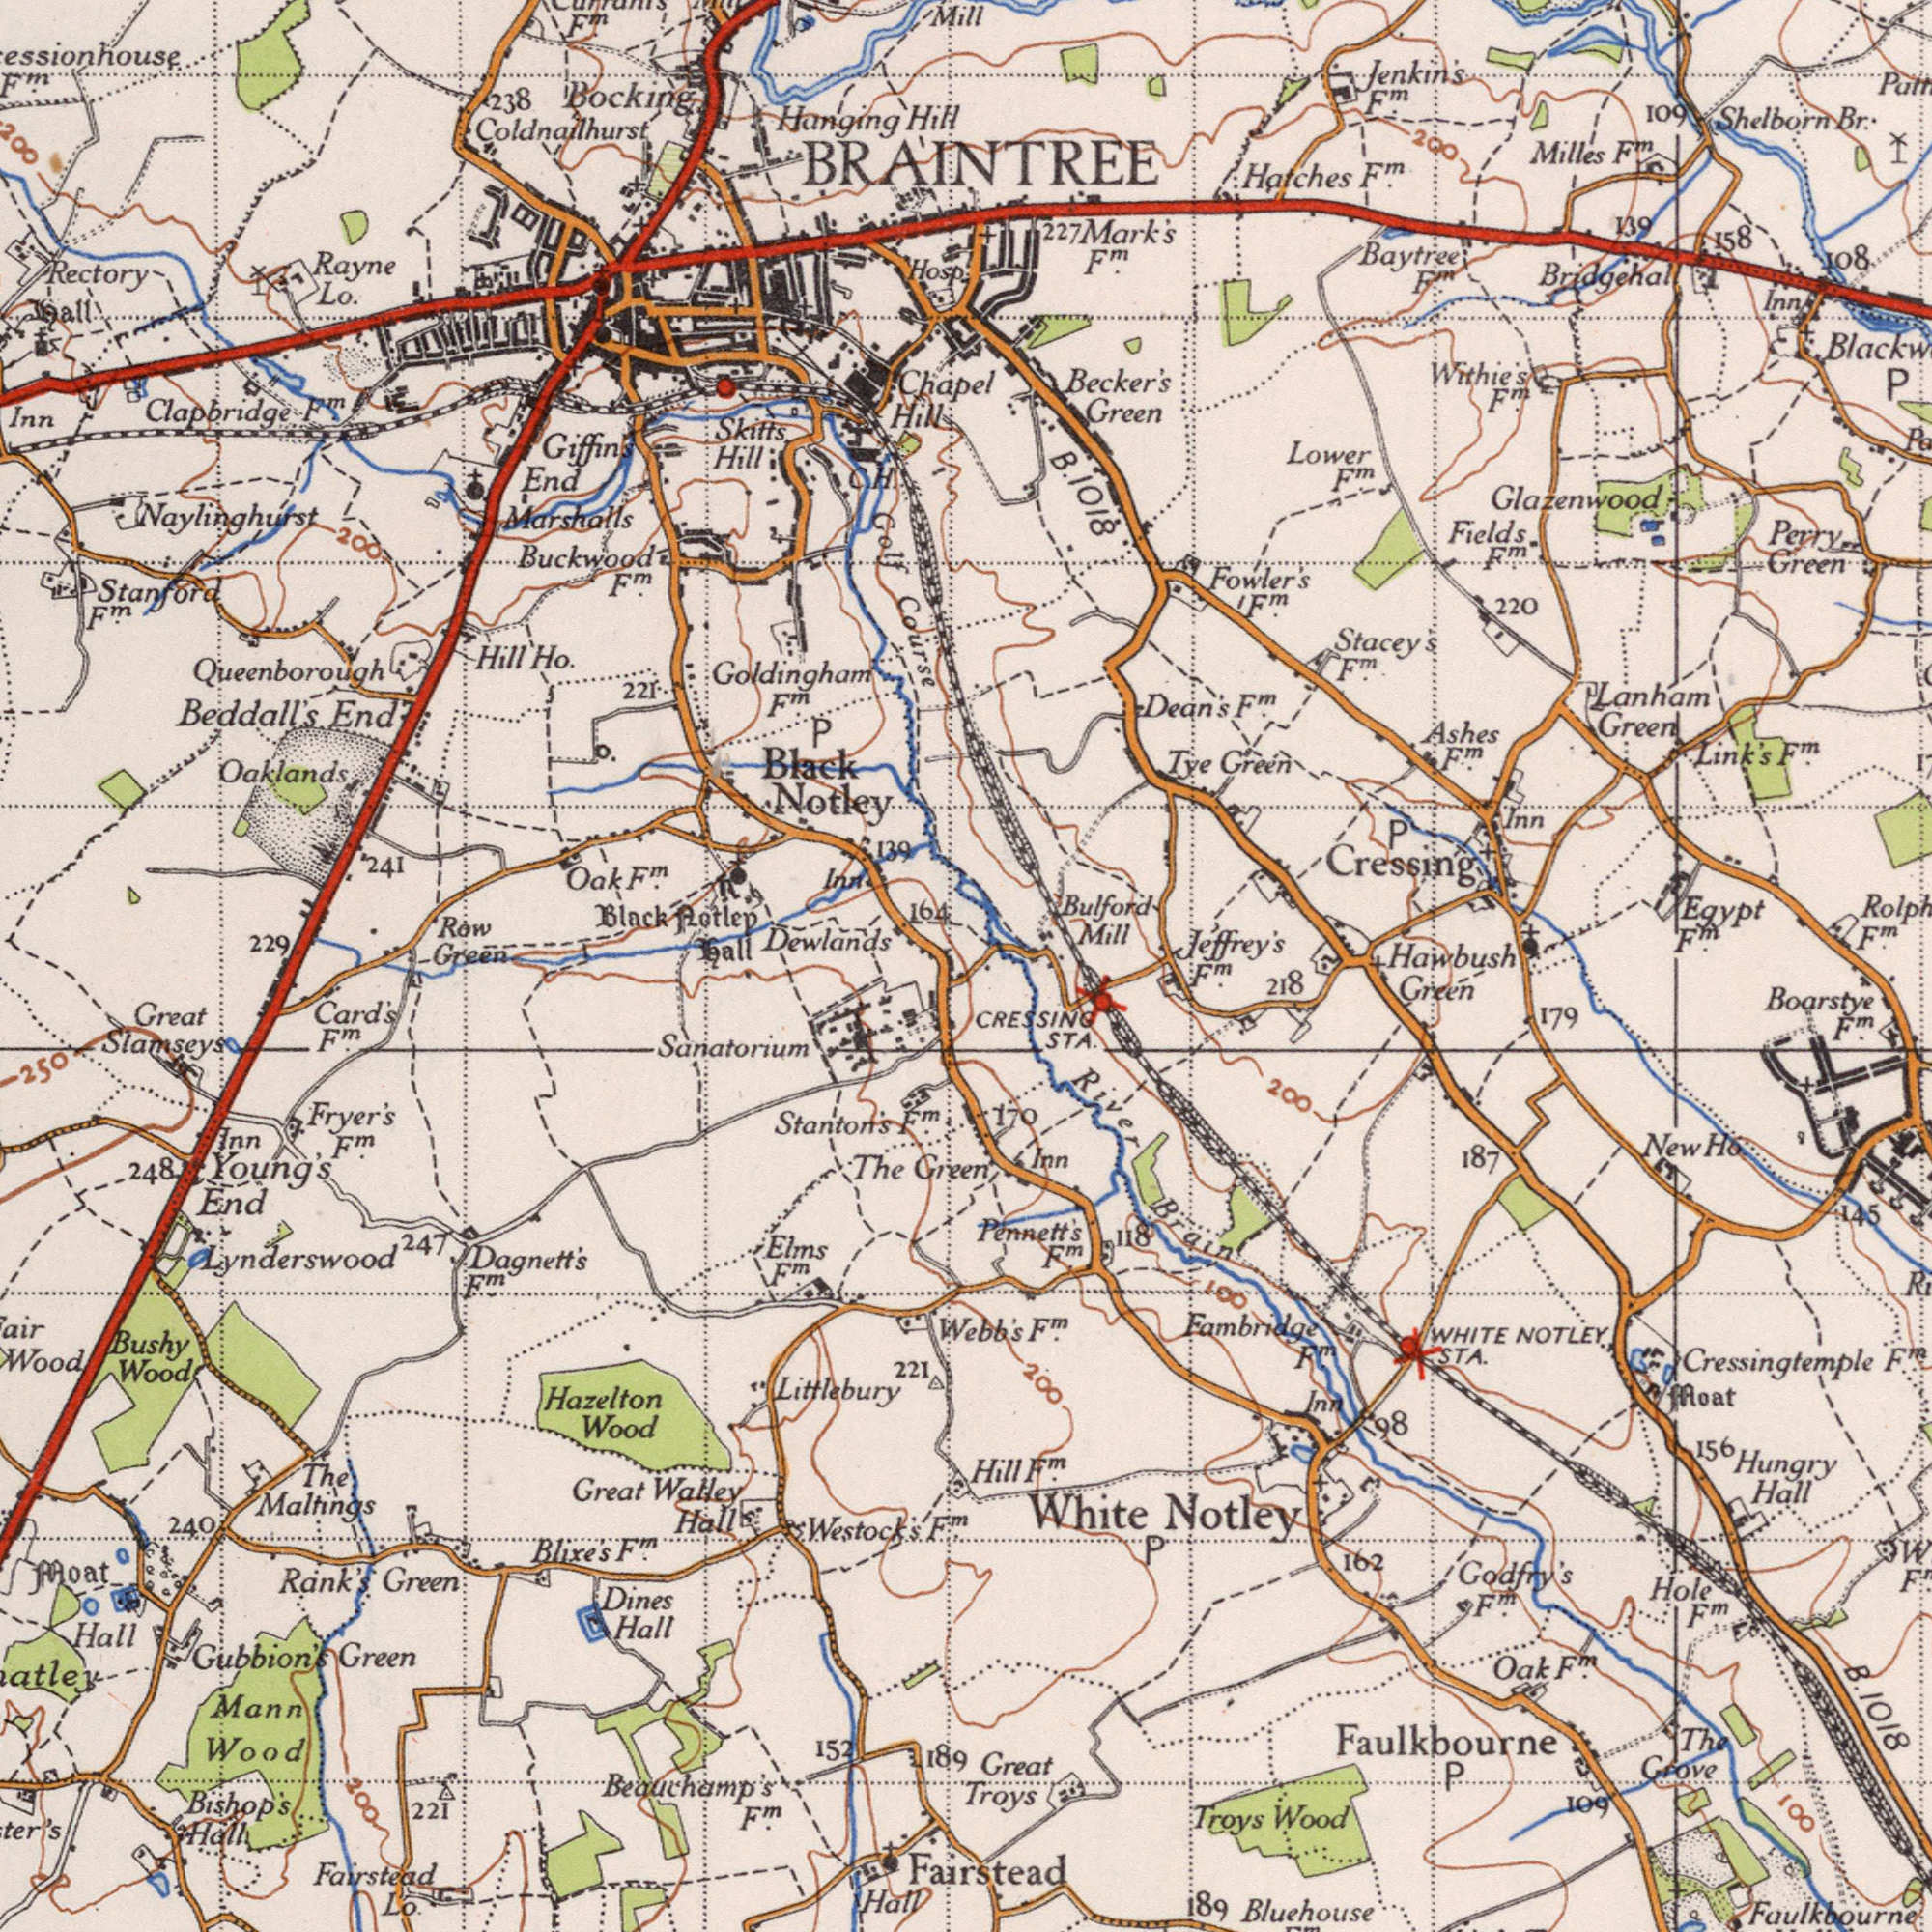What text is visible in the upper-right corner? BRAINTREE Glazenwood Bridgehall Shelborn Becker's Milles Bulford Hatches Green Jeffrey's Mill Egypt Link's Cressing Baytree Green Green Hawbush Green Fowler's Fields Br: Ashes Mark's Withie's Stacey's Tye 220 Dean's Jenkin's 108 109 139 Inn Lower Perry 158 F<sup>m</sup>. F<sup>m</sup>. F<sup>m</sup>. F<sup>m</sup>. Inn F<sup>m</sup>. 227 F<sup>m</sup>. F<sup>m</sup>. F<sup>m</sup>. P F<sup>m</sup>. F<sup>m</sup>. F<sup>m</sup>. F<sup>m</sup>. F<sup>m</sup>. F<sup>m</sup>. F<sup>m</sup>. Lanham P 200 B. 1018 What text is shown in the bottom-left quadrant? Sanatorium Hazelton Gubbion's Wood Card's Wood Fairstead Stanton's Beauchamp's Wood Hall Blixe's Elms Westock's The F<sup>m</sup>. Mann Green Great Slamseys Dines Green Great Rank's End Lo. Hall Hall Young's 221 Hall Fryer's 221 F<sup>m</sup>. Bishop's Hall Bushy Moat Wood Green The 152 Inn 240 Littlebury 250 F<sup>m</sup>. F<sup>m</sup>. 247 Dagnett's F<sup>m</sup>. Maltings 189 F<sup>m</sup>. F<sup>m</sup>. F<sup>m</sup>. 248 Watley Lynderswood 200 What text is shown in the top-left quadrant? Buckwood Marshalls Notley Coldnailhurst Rectory Goldingham Black Hanging Beddall's Dewlands Row Oaklands Black Inn Clapbridge Course Stanford End Rotlep Skitts Hill Hill 221 Inn Ho. 164 Rayne Lo. End Green 229 Mill Bocking F<sup>m</sup>. F<sup>m</sup>. Hill Hosp Hill 238 P 200 O. 139 ###all ###all Chapel F<sup>m</sup>. F<sup>m</sup>. Golf C. F<sup>m</sup>. 241 Giffin's Oak Queenborough Naylinghurst F<sup>m</sup>. H. What text appears in the bottom-right area of the image? Fairstead Bluehouse Boarstye Hungry Troys STA. Great Cressingtemple Pennett's Troys Wood CRESSING 156 Green Grove STA. 1018 WHITE NOTLEY Hole 218 187 Notley F<sup>m</sup>. 162 Faulkbourne Hall F<sup>m</sup>. 189 179 Oak The 109 Inn 145 200 Hill 100 F<sup>m</sup>. F<sup>m</sup>. River 170 Faulkbourne P Inn P Moat Webb's 100 F<sup>m</sup>. 200 Ho Godfry's F<sup>m</sup>. Fambridge F<sup>m</sup>. White New F<sup>m</sup>. Brain F<sup>m</sup>. 118 98 F<sup>m</sup>. B. 